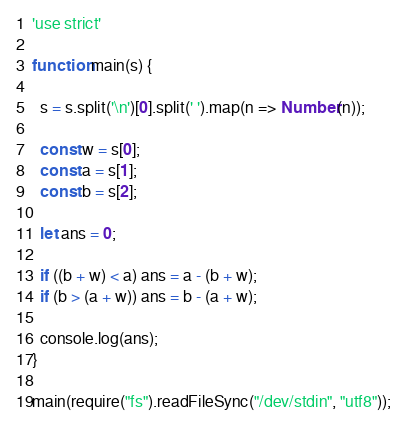<code> <loc_0><loc_0><loc_500><loc_500><_JavaScript_>'use strict'

function main(s) {

  s = s.split('\n')[0].split(' ').map(n => Number(n));

  const w = s[0];
  const a = s[1];
  const b = s[2];

  let ans = 0;

  if ((b + w) < a) ans = a - (b + w);
  if (b > (a + w)) ans = b - (a + w);

  console.log(ans);
}

main(require("fs").readFileSync("/dev/stdin", "utf8"));
</code> 